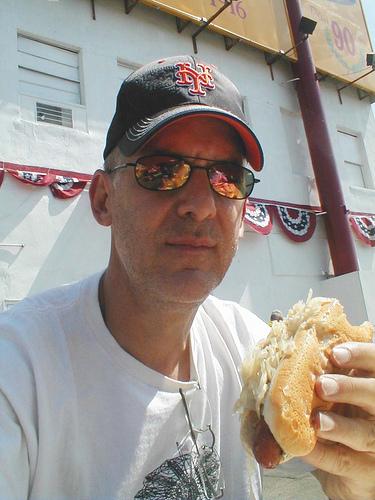Does the man have eyeglasses on his shirt?
Write a very short answer. Yes. Does this man enjoy street food?
Give a very brief answer. Yes. What color is the cap of the man?
Give a very brief answer. Black. 